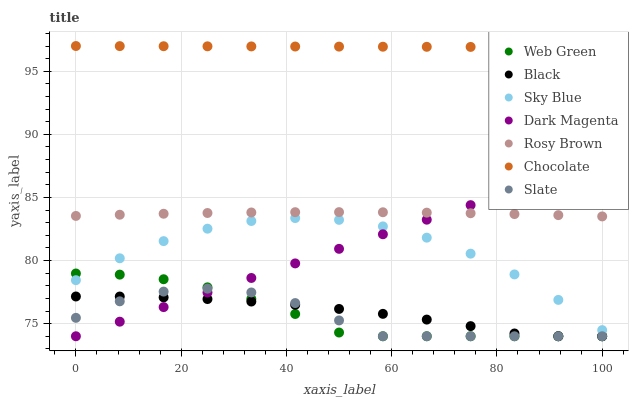Does Slate have the minimum area under the curve?
Answer yes or no. Yes. Does Chocolate have the maximum area under the curve?
Answer yes or no. Yes. Does Rosy Brown have the minimum area under the curve?
Answer yes or no. No. Does Rosy Brown have the maximum area under the curve?
Answer yes or no. No. Is Chocolate the smoothest?
Answer yes or no. Yes. Is Sky Blue the roughest?
Answer yes or no. Yes. Is Slate the smoothest?
Answer yes or no. No. Is Slate the roughest?
Answer yes or no. No. Does Dark Magenta have the lowest value?
Answer yes or no. Yes. Does Rosy Brown have the lowest value?
Answer yes or no. No. Does Chocolate have the highest value?
Answer yes or no. Yes. Does Slate have the highest value?
Answer yes or no. No. Is Dark Magenta less than Chocolate?
Answer yes or no. Yes. Is Chocolate greater than Rosy Brown?
Answer yes or no. Yes. Does Web Green intersect Dark Magenta?
Answer yes or no. Yes. Is Web Green less than Dark Magenta?
Answer yes or no. No. Is Web Green greater than Dark Magenta?
Answer yes or no. No. Does Dark Magenta intersect Chocolate?
Answer yes or no. No. 